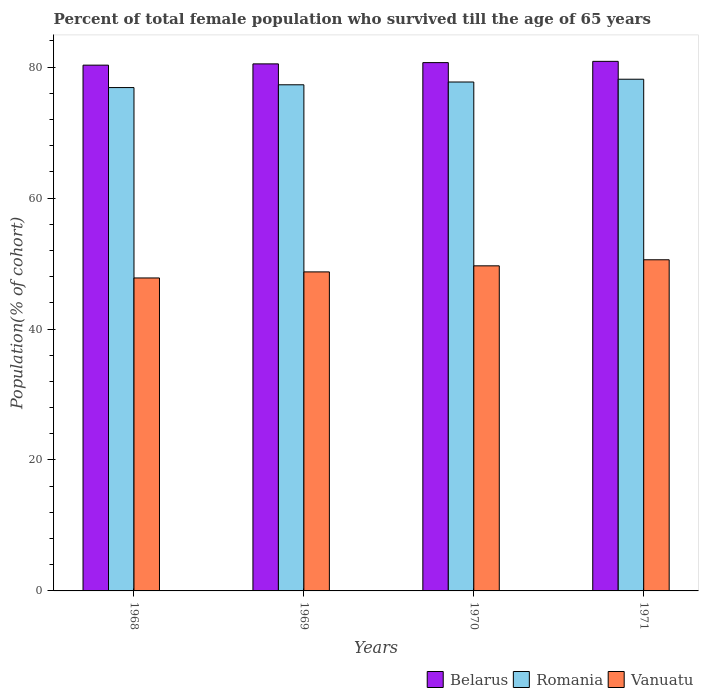How many groups of bars are there?
Give a very brief answer. 4. How many bars are there on the 1st tick from the left?
Give a very brief answer. 3. How many bars are there on the 2nd tick from the right?
Provide a succinct answer. 3. What is the label of the 2nd group of bars from the left?
Keep it short and to the point. 1969. In how many cases, is the number of bars for a given year not equal to the number of legend labels?
Give a very brief answer. 0. What is the percentage of total female population who survived till the age of 65 years in Belarus in 1970?
Keep it short and to the point. 80.69. Across all years, what is the maximum percentage of total female population who survived till the age of 65 years in Romania?
Provide a succinct answer. 78.15. Across all years, what is the minimum percentage of total female population who survived till the age of 65 years in Vanuatu?
Provide a succinct answer. 47.8. In which year was the percentage of total female population who survived till the age of 65 years in Belarus maximum?
Provide a short and direct response. 1971. In which year was the percentage of total female population who survived till the age of 65 years in Vanuatu minimum?
Keep it short and to the point. 1968. What is the total percentage of total female population who survived till the age of 65 years in Romania in the graph?
Ensure brevity in your answer.  310.06. What is the difference between the percentage of total female population who survived till the age of 65 years in Belarus in 1968 and that in 1970?
Ensure brevity in your answer.  -0.39. What is the difference between the percentage of total female population who survived till the age of 65 years in Romania in 1968 and the percentage of total female population who survived till the age of 65 years in Belarus in 1969?
Offer a terse response. -3.62. What is the average percentage of total female population who survived till the age of 65 years in Romania per year?
Make the answer very short. 77.52. In the year 1969, what is the difference between the percentage of total female population who survived till the age of 65 years in Belarus and percentage of total female population who survived till the age of 65 years in Romania?
Make the answer very short. 3.19. In how many years, is the percentage of total female population who survived till the age of 65 years in Belarus greater than 4 %?
Give a very brief answer. 4. What is the ratio of the percentage of total female population who survived till the age of 65 years in Vanuatu in 1970 to that in 1971?
Provide a short and direct response. 0.98. Is the percentage of total female population who survived till the age of 65 years in Romania in 1970 less than that in 1971?
Keep it short and to the point. Yes. Is the difference between the percentage of total female population who survived till the age of 65 years in Belarus in 1968 and 1969 greater than the difference between the percentage of total female population who survived till the age of 65 years in Romania in 1968 and 1969?
Your response must be concise. Yes. What is the difference between the highest and the second highest percentage of total female population who survived till the age of 65 years in Belarus?
Ensure brevity in your answer.  0.19. What is the difference between the highest and the lowest percentage of total female population who survived till the age of 65 years in Belarus?
Keep it short and to the point. 0.58. In how many years, is the percentage of total female population who survived till the age of 65 years in Belarus greater than the average percentage of total female population who survived till the age of 65 years in Belarus taken over all years?
Give a very brief answer. 2. Is the sum of the percentage of total female population who survived till the age of 65 years in Romania in 1970 and 1971 greater than the maximum percentage of total female population who survived till the age of 65 years in Vanuatu across all years?
Give a very brief answer. Yes. What does the 3rd bar from the left in 1968 represents?
Offer a terse response. Vanuatu. What does the 2nd bar from the right in 1968 represents?
Your response must be concise. Romania. Is it the case that in every year, the sum of the percentage of total female population who survived till the age of 65 years in Belarus and percentage of total female population who survived till the age of 65 years in Romania is greater than the percentage of total female population who survived till the age of 65 years in Vanuatu?
Provide a succinct answer. Yes. What is the difference between two consecutive major ticks on the Y-axis?
Keep it short and to the point. 20. Are the values on the major ticks of Y-axis written in scientific E-notation?
Your answer should be compact. No. Does the graph contain grids?
Provide a succinct answer. No. How many legend labels are there?
Your answer should be compact. 3. What is the title of the graph?
Your answer should be very brief. Percent of total female population who survived till the age of 65 years. What is the label or title of the X-axis?
Your response must be concise. Years. What is the label or title of the Y-axis?
Keep it short and to the point. Population(% of cohort). What is the Population(% of cohort) of Belarus in 1968?
Provide a succinct answer. 80.3. What is the Population(% of cohort) of Romania in 1968?
Offer a very short reply. 76.88. What is the Population(% of cohort) in Vanuatu in 1968?
Your answer should be compact. 47.8. What is the Population(% of cohort) in Belarus in 1969?
Provide a short and direct response. 80.5. What is the Population(% of cohort) of Romania in 1969?
Keep it short and to the point. 77.3. What is the Population(% of cohort) of Vanuatu in 1969?
Keep it short and to the point. 48.73. What is the Population(% of cohort) in Belarus in 1970?
Offer a very short reply. 80.69. What is the Population(% of cohort) of Romania in 1970?
Give a very brief answer. 77.73. What is the Population(% of cohort) in Vanuatu in 1970?
Offer a very short reply. 49.65. What is the Population(% of cohort) in Belarus in 1971?
Ensure brevity in your answer.  80.88. What is the Population(% of cohort) of Romania in 1971?
Provide a succinct answer. 78.15. What is the Population(% of cohort) in Vanuatu in 1971?
Ensure brevity in your answer.  50.58. Across all years, what is the maximum Population(% of cohort) of Belarus?
Give a very brief answer. 80.88. Across all years, what is the maximum Population(% of cohort) of Romania?
Give a very brief answer. 78.15. Across all years, what is the maximum Population(% of cohort) in Vanuatu?
Offer a very short reply. 50.58. Across all years, what is the minimum Population(% of cohort) of Belarus?
Offer a very short reply. 80.3. Across all years, what is the minimum Population(% of cohort) in Romania?
Your answer should be compact. 76.88. Across all years, what is the minimum Population(% of cohort) of Vanuatu?
Ensure brevity in your answer.  47.8. What is the total Population(% of cohort) in Belarus in the graph?
Your answer should be very brief. 322.38. What is the total Population(% of cohort) in Romania in the graph?
Ensure brevity in your answer.  310.06. What is the total Population(% of cohort) of Vanuatu in the graph?
Offer a terse response. 196.75. What is the difference between the Population(% of cohort) of Belarus in 1968 and that in 1969?
Keep it short and to the point. -0.19. What is the difference between the Population(% of cohort) of Romania in 1968 and that in 1969?
Offer a very short reply. -0.43. What is the difference between the Population(% of cohort) in Vanuatu in 1968 and that in 1969?
Provide a succinct answer. -0.93. What is the difference between the Population(% of cohort) of Belarus in 1968 and that in 1970?
Your answer should be compact. -0.39. What is the difference between the Population(% of cohort) in Romania in 1968 and that in 1970?
Give a very brief answer. -0.85. What is the difference between the Population(% of cohort) of Vanuatu in 1968 and that in 1970?
Your answer should be very brief. -1.85. What is the difference between the Population(% of cohort) in Belarus in 1968 and that in 1971?
Give a very brief answer. -0.58. What is the difference between the Population(% of cohort) in Romania in 1968 and that in 1971?
Make the answer very short. -1.28. What is the difference between the Population(% of cohort) of Vanuatu in 1968 and that in 1971?
Ensure brevity in your answer.  -2.78. What is the difference between the Population(% of cohort) in Belarus in 1969 and that in 1970?
Your answer should be very brief. -0.19. What is the difference between the Population(% of cohort) in Romania in 1969 and that in 1970?
Your response must be concise. -0.43. What is the difference between the Population(% of cohort) in Vanuatu in 1969 and that in 1970?
Offer a terse response. -0.93. What is the difference between the Population(% of cohort) of Belarus in 1969 and that in 1971?
Offer a very short reply. -0.39. What is the difference between the Population(% of cohort) in Romania in 1969 and that in 1971?
Offer a very short reply. -0.85. What is the difference between the Population(% of cohort) of Vanuatu in 1969 and that in 1971?
Give a very brief answer. -1.85. What is the difference between the Population(% of cohort) in Belarus in 1970 and that in 1971?
Provide a succinct answer. -0.19. What is the difference between the Population(% of cohort) of Romania in 1970 and that in 1971?
Ensure brevity in your answer.  -0.43. What is the difference between the Population(% of cohort) of Vanuatu in 1970 and that in 1971?
Give a very brief answer. -0.93. What is the difference between the Population(% of cohort) of Belarus in 1968 and the Population(% of cohort) of Romania in 1969?
Make the answer very short. 3. What is the difference between the Population(% of cohort) in Belarus in 1968 and the Population(% of cohort) in Vanuatu in 1969?
Give a very brief answer. 31.58. What is the difference between the Population(% of cohort) of Romania in 1968 and the Population(% of cohort) of Vanuatu in 1969?
Offer a terse response. 28.15. What is the difference between the Population(% of cohort) of Belarus in 1968 and the Population(% of cohort) of Romania in 1970?
Provide a short and direct response. 2.58. What is the difference between the Population(% of cohort) of Belarus in 1968 and the Population(% of cohort) of Vanuatu in 1970?
Provide a succinct answer. 30.65. What is the difference between the Population(% of cohort) in Romania in 1968 and the Population(% of cohort) in Vanuatu in 1970?
Ensure brevity in your answer.  27.23. What is the difference between the Population(% of cohort) in Belarus in 1968 and the Population(% of cohort) in Romania in 1971?
Provide a short and direct response. 2.15. What is the difference between the Population(% of cohort) of Belarus in 1968 and the Population(% of cohort) of Vanuatu in 1971?
Offer a very short reply. 29.73. What is the difference between the Population(% of cohort) in Romania in 1968 and the Population(% of cohort) in Vanuatu in 1971?
Provide a succinct answer. 26.3. What is the difference between the Population(% of cohort) in Belarus in 1969 and the Population(% of cohort) in Romania in 1970?
Provide a succinct answer. 2.77. What is the difference between the Population(% of cohort) in Belarus in 1969 and the Population(% of cohort) in Vanuatu in 1970?
Keep it short and to the point. 30.85. What is the difference between the Population(% of cohort) in Romania in 1969 and the Population(% of cohort) in Vanuatu in 1970?
Your answer should be compact. 27.65. What is the difference between the Population(% of cohort) in Belarus in 1969 and the Population(% of cohort) in Romania in 1971?
Keep it short and to the point. 2.34. What is the difference between the Population(% of cohort) in Belarus in 1969 and the Population(% of cohort) in Vanuatu in 1971?
Your answer should be compact. 29.92. What is the difference between the Population(% of cohort) of Romania in 1969 and the Population(% of cohort) of Vanuatu in 1971?
Provide a short and direct response. 26.73. What is the difference between the Population(% of cohort) of Belarus in 1970 and the Population(% of cohort) of Romania in 1971?
Your answer should be compact. 2.54. What is the difference between the Population(% of cohort) in Belarus in 1970 and the Population(% of cohort) in Vanuatu in 1971?
Offer a terse response. 30.11. What is the difference between the Population(% of cohort) of Romania in 1970 and the Population(% of cohort) of Vanuatu in 1971?
Your response must be concise. 27.15. What is the average Population(% of cohort) in Belarus per year?
Give a very brief answer. 80.59. What is the average Population(% of cohort) of Romania per year?
Ensure brevity in your answer.  77.52. What is the average Population(% of cohort) in Vanuatu per year?
Make the answer very short. 49.19. In the year 1968, what is the difference between the Population(% of cohort) in Belarus and Population(% of cohort) in Romania?
Provide a short and direct response. 3.43. In the year 1968, what is the difference between the Population(% of cohort) in Belarus and Population(% of cohort) in Vanuatu?
Keep it short and to the point. 32.5. In the year 1968, what is the difference between the Population(% of cohort) of Romania and Population(% of cohort) of Vanuatu?
Offer a very short reply. 29.08. In the year 1969, what is the difference between the Population(% of cohort) of Belarus and Population(% of cohort) of Romania?
Your response must be concise. 3.19. In the year 1969, what is the difference between the Population(% of cohort) in Belarus and Population(% of cohort) in Vanuatu?
Offer a terse response. 31.77. In the year 1969, what is the difference between the Population(% of cohort) of Romania and Population(% of cohort) of Vanuatu?
Offer a very short reply. 28.58. In the year 1970, what is the difference between the Population(% of cohort) in Belarus and Population(% of cohort) in Romania?
Your answer should be compact. 2.96. In the year 1970, what is the difference between the Population(% of cohort) in Belarus and Population(% of cohort) in Vanuatu?
Offer a terse response. 31.04. In the year 1970, what is the difference between the Population(% of cohort) of Romania and Population(% of cohort) of Vanuatu?
Provide a short and direct response. 28.08. In the year 1971, what is the difference between the Population(% of cohort) in Belarus and Population(% of cohort) in Romania?
Your answer should be compact. 2.73. In the year 1971, what is the difference between the Population(% of cohort) in Belarus and Population(% of cohort) in Vanuatu?
Your answer should be very brief. 30.31. In the year 1971, what is the difference between the Population(% of cohort) in Romania and Population(% of cohort) in Vanuatu?
Provide a succinct answer. 27.58. What is the ratio of the Population(% of cohort) of Romania in 1968 to that in 1969?
Keep it short and to the point. 0.99. What is the ratio of the Population(% of cohort) in Belarus in 1968 to that in 1970?
Your response must be concise. 1. What is the ratio of the Population(% of cohort) in Romania in 1968 to that in 1970?
Give a very brief answer. 0.99. What is the ratio of the Population(% of cohort) of Vanuatu in 1968 to that in 1970?
Your response must be concise. 0.96. What is the ratio of the Population(% of cohort) in Belarus in 1968 to that in 1971?
Your answer should be very brief. 0.99. What is the ratio of the Population(% of cohort) of Romania in 1968 to that in 1971?
Your answer should be very brief. 0.98. What is the ratio of the Population(% of cohort) of Vanuatu in 1968 to that in 1971?
Your answer should be compact. 0.95. What is the ratio of the Population(% of cohort) in Belarus in 1969 to that in 1970?
Offer a terse response. 1. What is the ratio of the Population(% of cohort) in Vanuatu in 1969 to that in 1970?
Your answer should be very brief. 0.98. What is the ratio of the Population(% of cohort) in Belarus in 1969 to that in 1971?
Offer a very short reply. 1. What is the ratio of the Population(% of cohort) in Romania in 1969 to that in 1971?
Give a very brief answer. 0.99. What is the ratio of the Population(% of cohort) in Vanuatu in 1969 to that in 1971?
Provide a short and direct response. 0.96. What is the ratio of the Population(% of cohort) of Belarus in 1970 to that in 1971?
Provide a succinct answer. 1. What is the ratio of the Population(% of cohort) in Vanuatu in 1970 to that in 1971?
Offer a very short reply. 0.98. What is the difference between the highest and the second highest Population(% of cohort) of Belarus?
Offer a very short reply. 0.19. What is the difference between the highest and the second highest Population(% of cohort) of Romania?
Your response must be concise. 0.43. What is the difference between the highest and the second highest Population(% of cohort) in Vanuatu?
Your response must be concise. 0.93. What is the difference between the highest and the lowest Population(% of cohort) of Belarus?
Your answer should be very brief. 0.58. What is the difference between the highest and the lowest Population(% of cohort) of Romania?
Offer a terse response. 1.28. What is the difference between the highest and the lowest Population(% of cohort) in Vanuatu?
Offer a terse response. 2.78. 